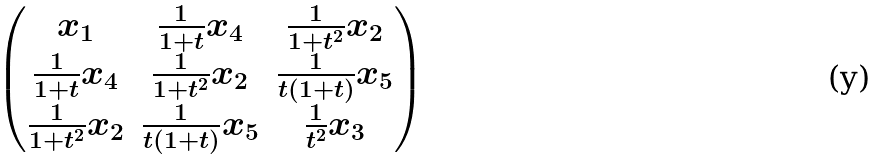Convert formula to latex. <formula><loc_0><loc_0><loc_500><loc_500>\begin{pmatrix} x _ { 1 } & \frac { 1 } { 1 + t } x _ { 4 } & \frac { 1 } { 1 + t ^ { 2 } } x _ { 2 } \\ \frac { 1 } { 1 + t } x _ { 4 } & \frac { 1 } { 1 + t ^ { 2 } } x _ { 2 } & \frac { 1 } { t ( 1 + t ) } x _ { 5 } \\ \frac { 1 } { 1 + t ^ { 2 } } x _ { 2 } & \frac { 1 } { t ( 1 + t ) } x _ { 5 } & \frac { 1 } { t ^ { 2 } } x _ { 3 } \end{pmatrix}</formula> 